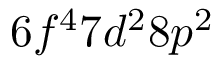Convert formula to latex. <formula><loc_0><loc_0><loc_500><loc_500>6 f ^ { 4 } 7 d ^ { 2 } 8 p ^ { 2 }</formula> 